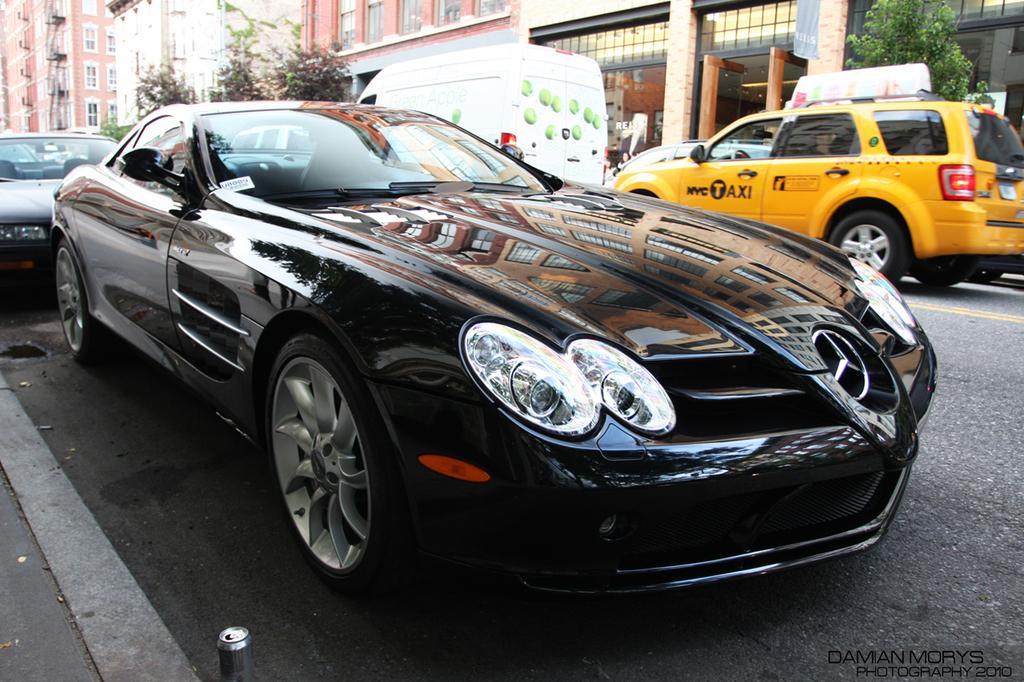Can you describe this image briefly? In this picture we can see few cars on the road, in the background we can find few trees and buildings. 